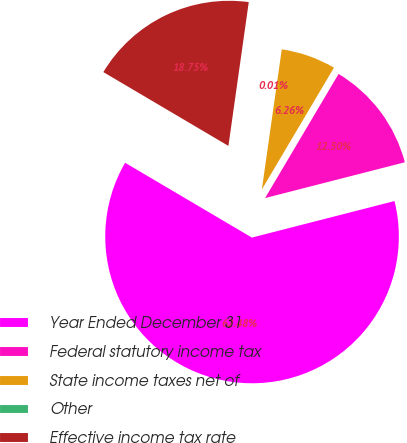Convert chart to OTSL. <chart><loc_0><loc_0><loc_500><loc_500><pie_chart><fcel>Year Ended December 31<fcel>Federal statutory income tax<fcel>State income taxes net of<fcel>Other<fcel>Effective income tax rate<nl><fcel>62.47%<fcel>12.5%<fcel>6.26%<fcel>0.01%<fcel>18.75%<nl></chart> 